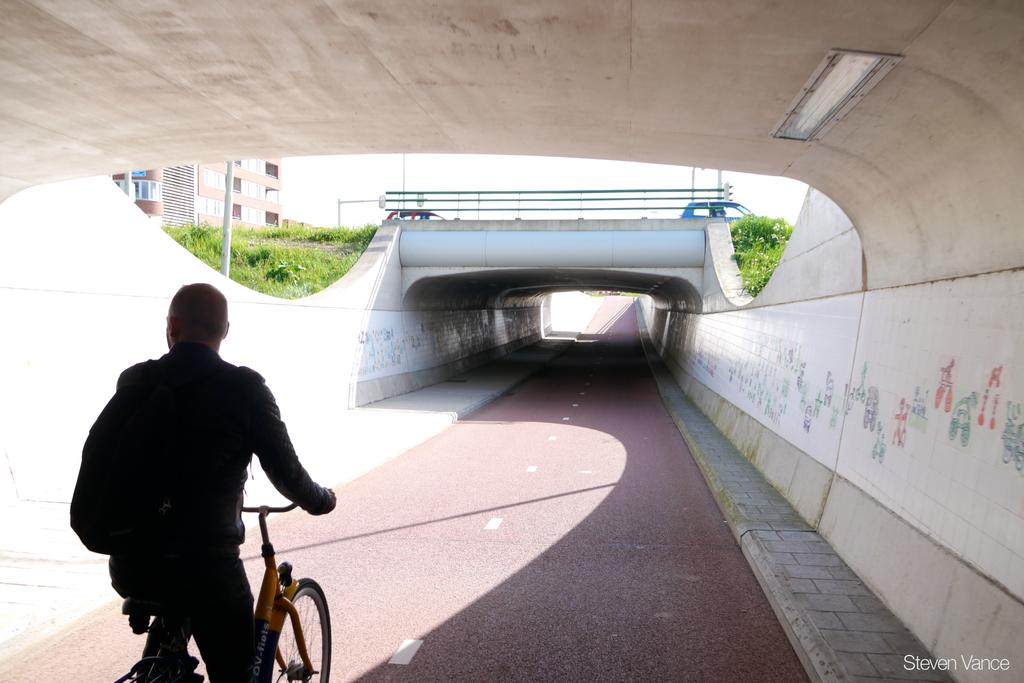What is the person in the image doing? The person is riding a cycle in the image. What is the person carrying while riding the cycle? The person is carrying a bag. What can be seen in the background of the image? There are vehicles, grass, and a building visible in the background of the image. What is the value of the water bottle the person is carrying in the image? There is no water bottle present in the image, so it is not possible to determine its value. 